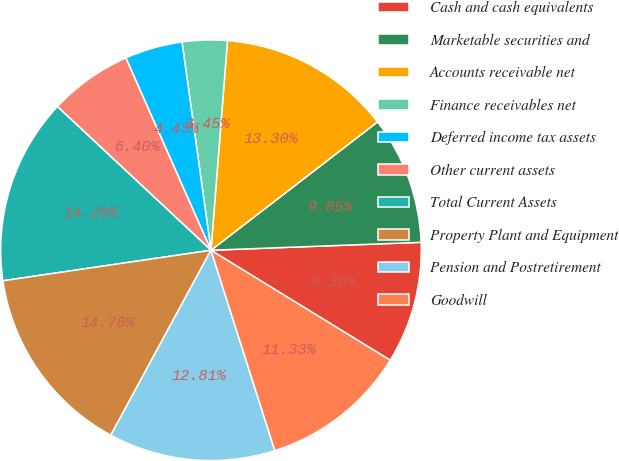<chart> <loc_0><loc_0><loc_500><loc_500><pie_chart><fcel>Cash and cash equivalents<fcel>Marketable securities and<fcel>Accounts receivable net<fcel>Finance receivables net<fcel>Deferred income tax assets<fcel>Other current assets<fcel>Total Current Assets<fcel>Property Plant and Equipment<fcel>Pension and Postretirement<fcel>Goodwill<nl><fcel>9.36%<fcel>9.85%<fcel>13.3%<fcel>3.45%<fcel>4.43%<fcel>6.4%<fcel>14.29%<fcel>14.78%<fcel>12.81%<fcel>11.33%<nl></chart> 